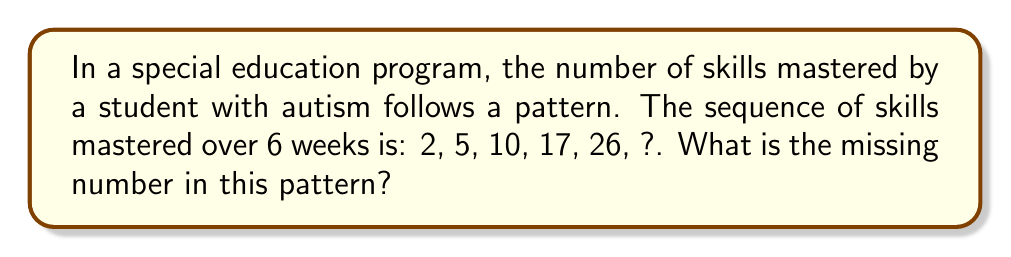Give your solution to this math problem. To solve this problem, let's analyze the pattern step-by-step:

1) First, calculate the differences between consecutive terms:
   $5 - 2 = 3$
   $10 - 5 = 5$
   $17 - 10 = 7$
   $26 - 17 = 9$

2) We can see that the differences form a pattern: 3, 5, 7, 9
   This is an arithmetic sequence with a common difference of 2.

3) Therefore, the next difference in this pattern would be 11.

4) To find the missing number, we add this difference to the last given term:
   $26 + 11 = 37$

5) We can verify this by looking at the general pattern:
   $a_n = a_{n-1} + 2n - 1$, where $n$ is the position in the sequence (starting from 1)

   For the 6th term: $a_6 = 26 + (2 * 6 - 1) = 26 + 11 = 37$

This pattern represents accelerating progress, which is common in special education as students build on previously mastered skills.
Answer: 37 